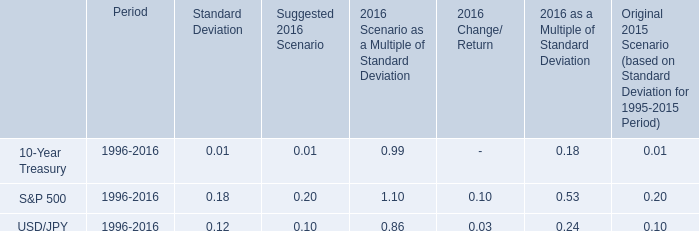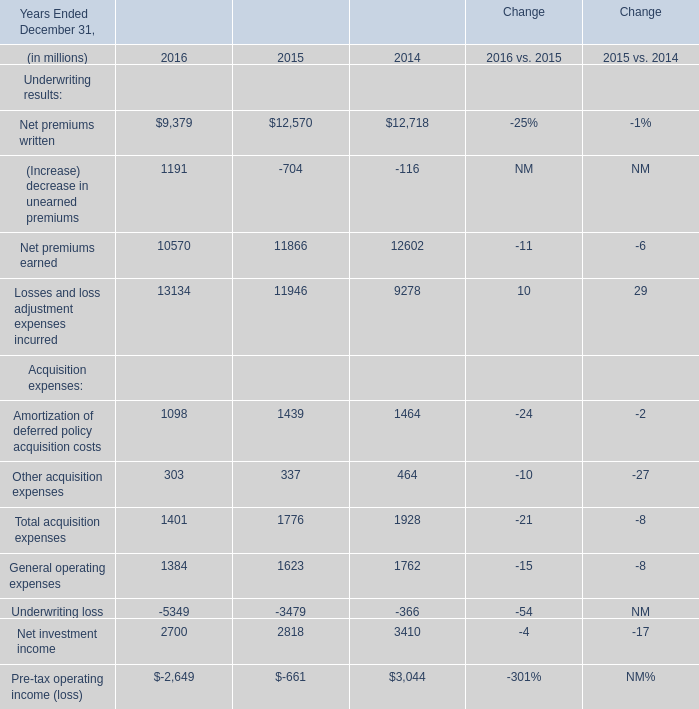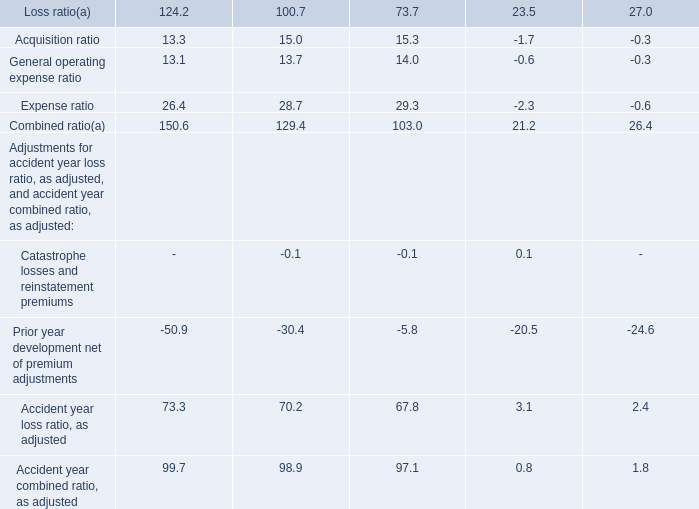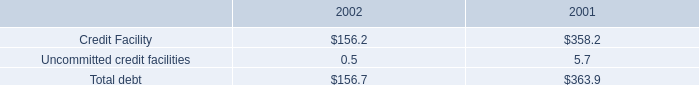what percent of the total debt is in the 2002 debt balance? 
Computations: (156.7 / (156.7 + 363.9))
Answer: 0.301. 